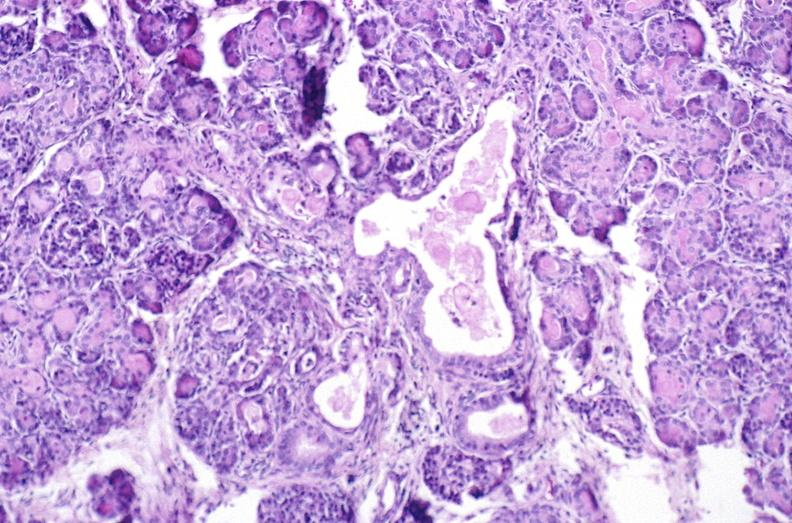s pancreas present?
Answer the question using a single word or phrase. Yes 